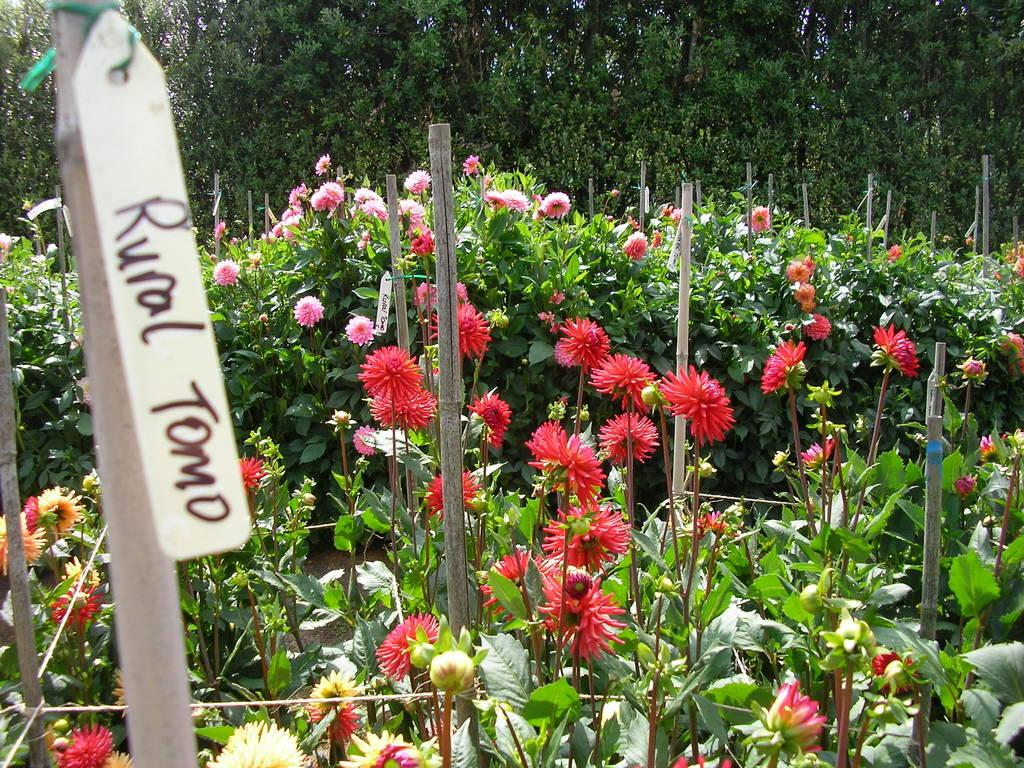What type of plants can be seen on the ground in the image? There are plants with flowers on the ground in the image. What other objects can be seen in the image? There are sticks and name cards visible in the image. What can be seen in the background of the image? There are trees visible in the background of the image. Can you tell me how many boats are docked at the harbor in the image? There is no harbor or boats present in the image. What type of twig is being used to measure the time in the image? There is no twig or watch present in the image. 